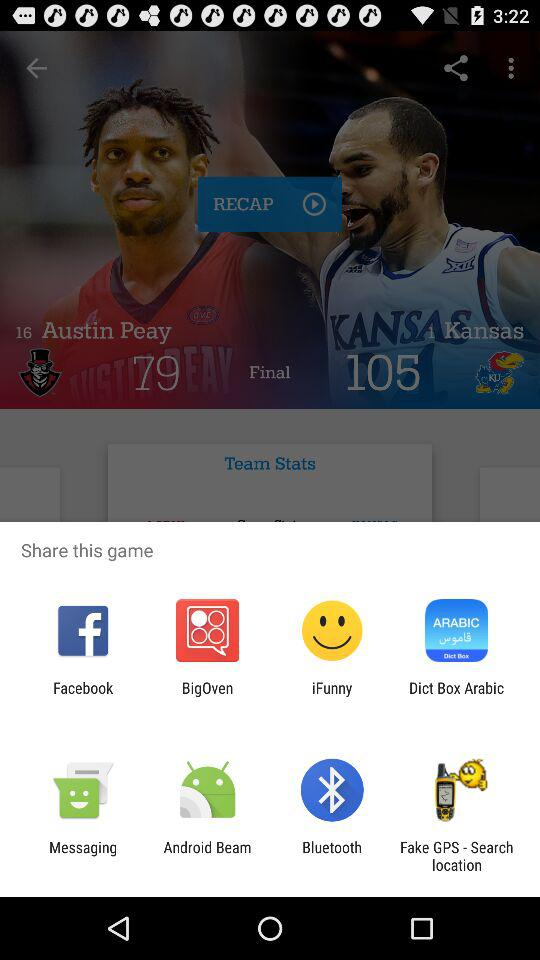What is the final score of "Kansas"? The final score is 105. 